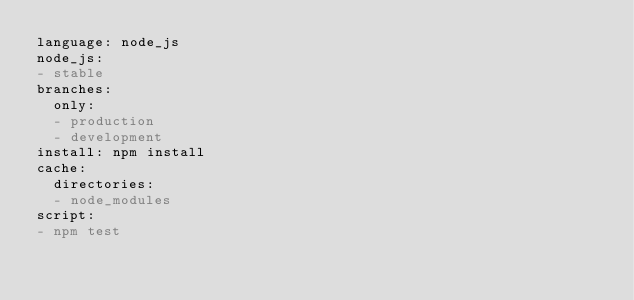<code> <loc_0><loc_0><loc_500><loc_500><_YAML_>language: node_js
node_js:
- stable
branches:
  only:
  - production
  - development
install: npm install
cache:
  directories:
  - node_modules
script:
- npm test
</code> 